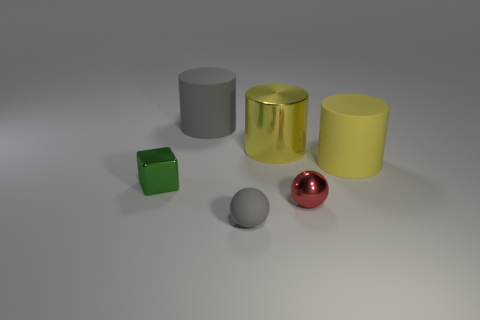Add 2 red things. How many objects exist? 8 Subtract all balls. How many objects are left? 4 Subtract 0 cyan balls. How many objects are left? 6 Subtract all small blue things. Subtract all big shiny cylinders. How many objects are left? 5 Add 1 rubber objects. How many rubber objects are left? 4 Add 1 large cyan rubber balls. How many large cyan rubber balls exist? 1 